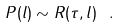Convert formula to latex. <formula><loc_0><loc_0><loc_500><loc_500>P ( l ) \sim R ( \tau , l ) \ .</formula> 